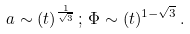Convert formula to latex. <formula><loc_0><loc_0><loc_500><loc_500>a \sim ( t ) ^ { \frac { 1 } { \sqrt { 3 } } } \, ; \, \Phi \sim ( t ) ^ { 1 - \sqrt { 3 } } \, .</formula> 